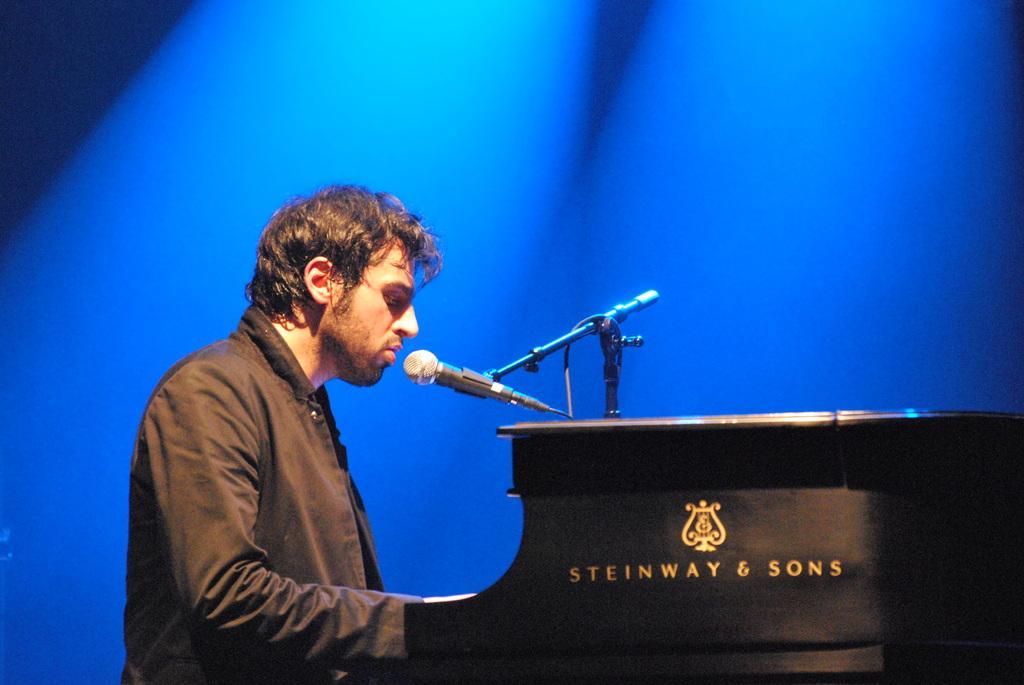Can you describe this image briefly? In the front of the image I can see a person, table, mic and stand. Something is written on the table. In this image I can see a blue background. 